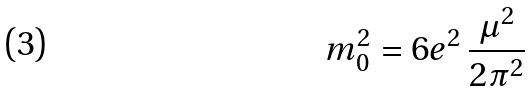<formula> <loc_0><loc_0><loc_500><loc_500>m _ { 0 } ^ { 2 } = 6 e ^ { 2 } \, { \frac { \mu ^ { 2 } } { 2 \pi ^ { 2 } } }</formula> 